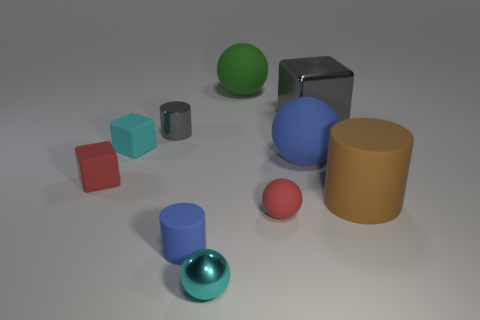Subtract all large cylinders. How many cylinders are left? 2 Subtract all cyan cubes. How many cubes are left? 2 Subtract all cubes. How many objects are left? 7 Subtract 1 balls. How many balls are left? 3 Subtract all blue cylinders. Subtract all blue spheres. How many cylinders are left? 2 Subtract all gray blocks. How many blue cylinders are left? 1 Subtract all cyan shiny spheres. Subtract all gray cylinders. How many objects are left? 8 Add 7 big shiny things. How many big shiny things are left? 8 Add 4 cyan metallic objects. How many cyan metallic objects exist? 5 Subtract 0 red cylinders. How many objects are left? 10 